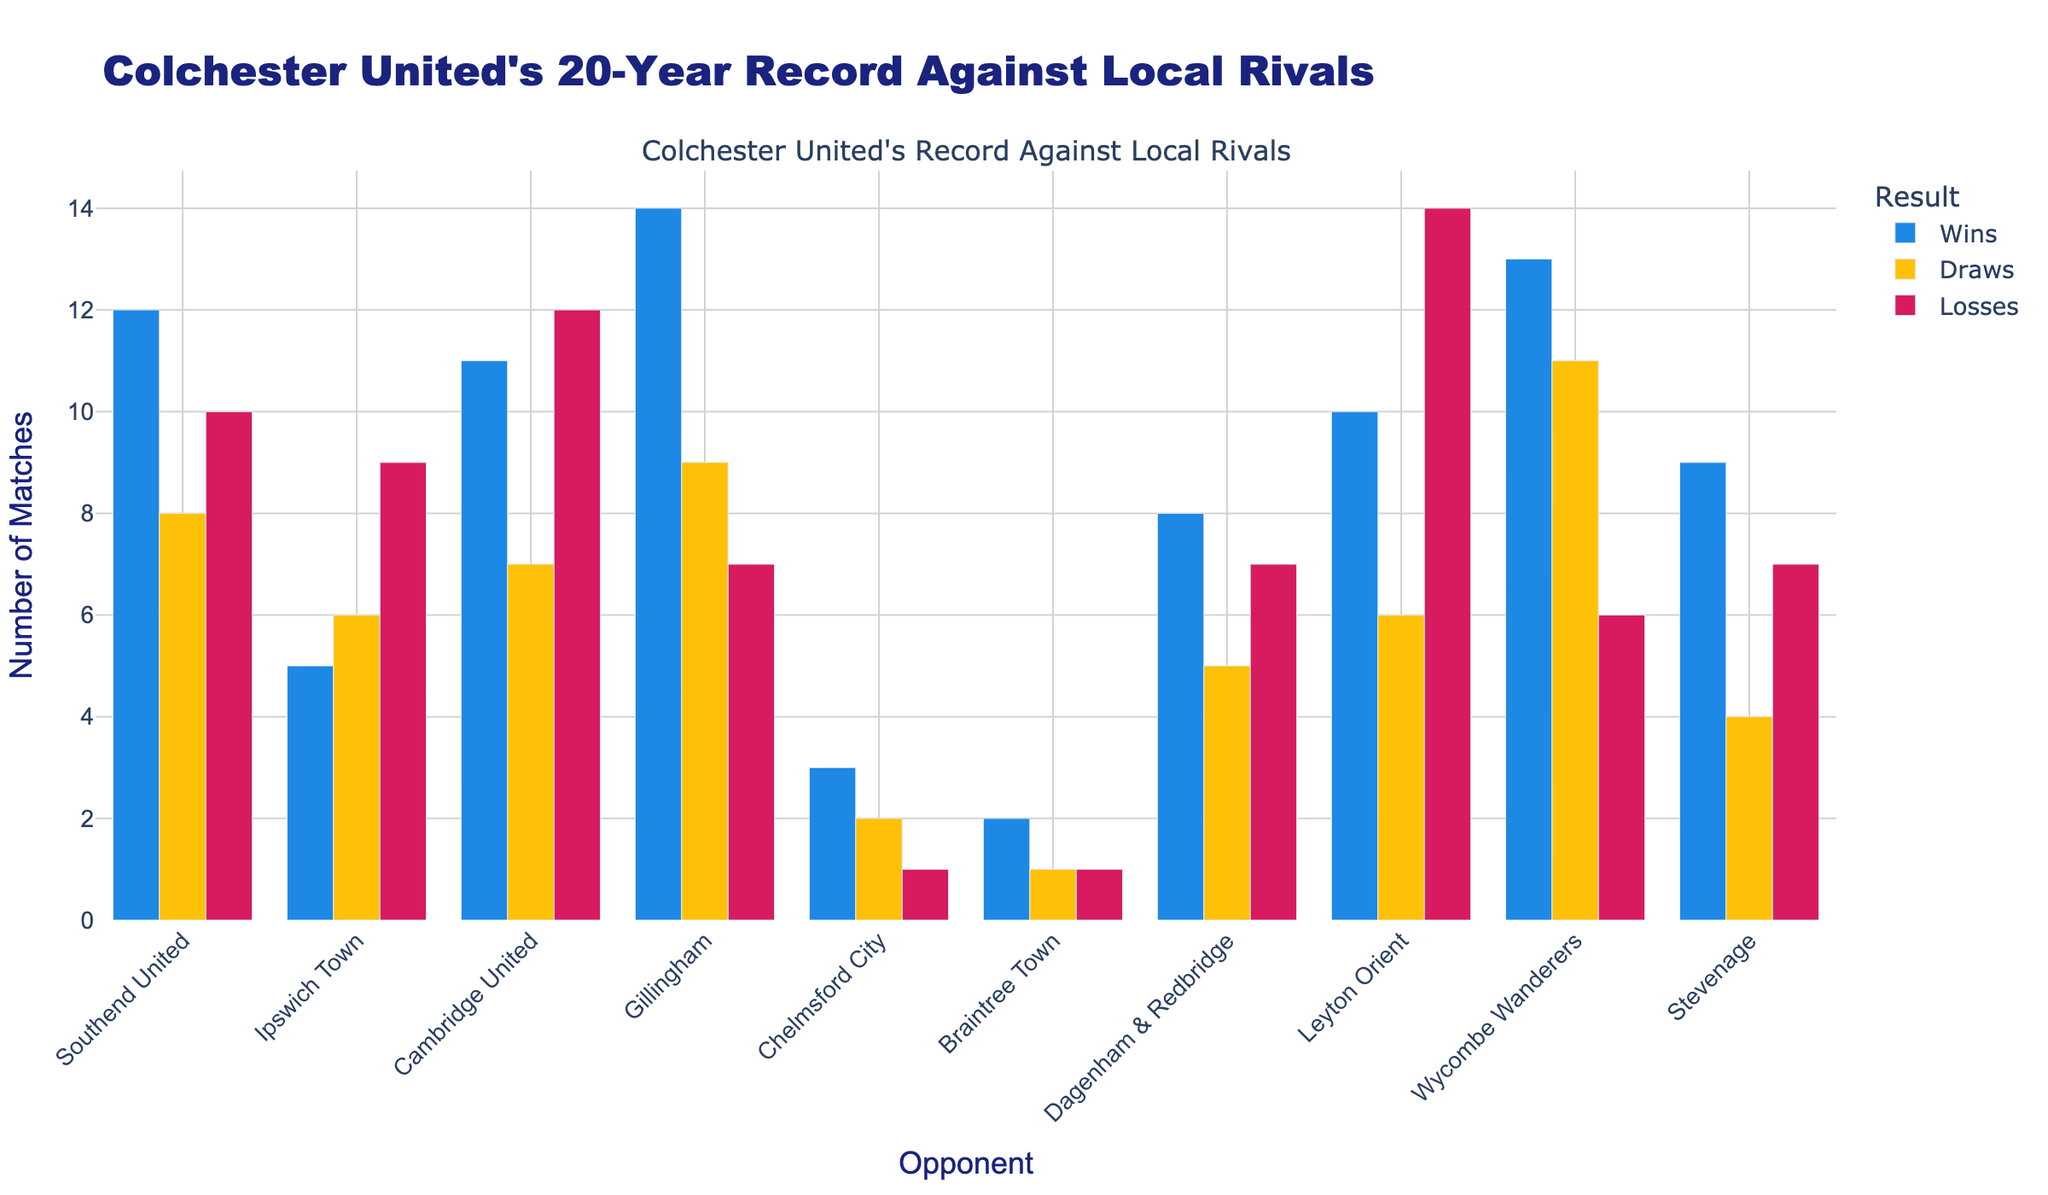what is the total number of wins, draws, and losses for Colchester United against all opponents? To find the total number of wins, draws, and losses, you sum up the respective counts for all opponents.
Wins: 12 + 5 + 11 + 14 + 3 + 2 + 8 + 10 + 13 + 9 = 87
Draws: 8 + 6 + 7 + 9 + 2 + 1 + 5 + 6 + 11 + 4 = 59
Losses: 10 + 9 + 12 + 7 + 1 + 1 + 7 + 14 + 6 + 7 = 74
Answer: 87 wins, 59 draws, 74 losses Which opponent has the highest number of draws against Colchester United? Look at the draws column and find the opponent with the highest number. The highest number of draws is 11, which is against Wycombe Wanderers.
Answer: Wycombe Wanderers Against which opponent does Colchester United have the fewest losses? To find the opponent with the fewest losses, look for the smallest number in the losses column. The smallest value is 1, which appears for Chelmsford City and Braintree Town.
Answer: Chelmsford City and Braintree Town How many more wins does Colchester United have against Gillingham compared to Ipswich Town? To find this, you subtract the number of wins against Ipswich Town from the number of wins against Gillingham. Wins against Ipswich Town: 5, wins against Gillingham: 14.
14 - 5 = 9
Answer: 9 What is the average number of matches Colchester United has played against Cambridge United in terms of wins, draws, and losses? To calculate the average, add the wins, draws, and losses, then divide by the number of match types (3).
Wins: 11, Draws: 7, Losses: 12
Total: 11 + 7 + 12 = 30
Average: 30 / 3 = 10
Answer: 10 Which opponent has a roughly equal number of wins, draws, and losses against Colchester United? To determine this, look for an opponent with similar values in the wins, draws, and losses columns. The closest match is Dagenham & Redbridge with wins: 8, draws: 5, and losses: 7.
Answer: Dagenham & Redbridge How does Colchester United's record against Southend United compare to their record against Leyton Orient in terms of wins and losses? Compare the number of wins and losses.
Southend United: Wins: 12, Losses: 10
Leyton Orient: Wins: 10, Losses: 14
Colchester United has more wins (2 more) and fewer losses (4 fewer) against Southend United compared to Leyton Orient.
Answer: More wins and fewer losses against Southend United What is the combined total of draws against Stevenage and Wycombe Wanderers? Add the number of draws against Stevenage (4) and Wycombe Wanderers (11).
4 + 11 = 15
Answer: 15 What is the most striking visual difference between the records against Chelmsford City and Braintree Town? Visually compare the heights of the bars for wins, draws, and losses against both opponents.
Chelmsford City has significantly more wins (3 vs. 2) and draws (2 vs. 1) compared to Braintree Town, while the number of losses is the same (1 each).
Answer: More wins and draws for Chelmsford City 